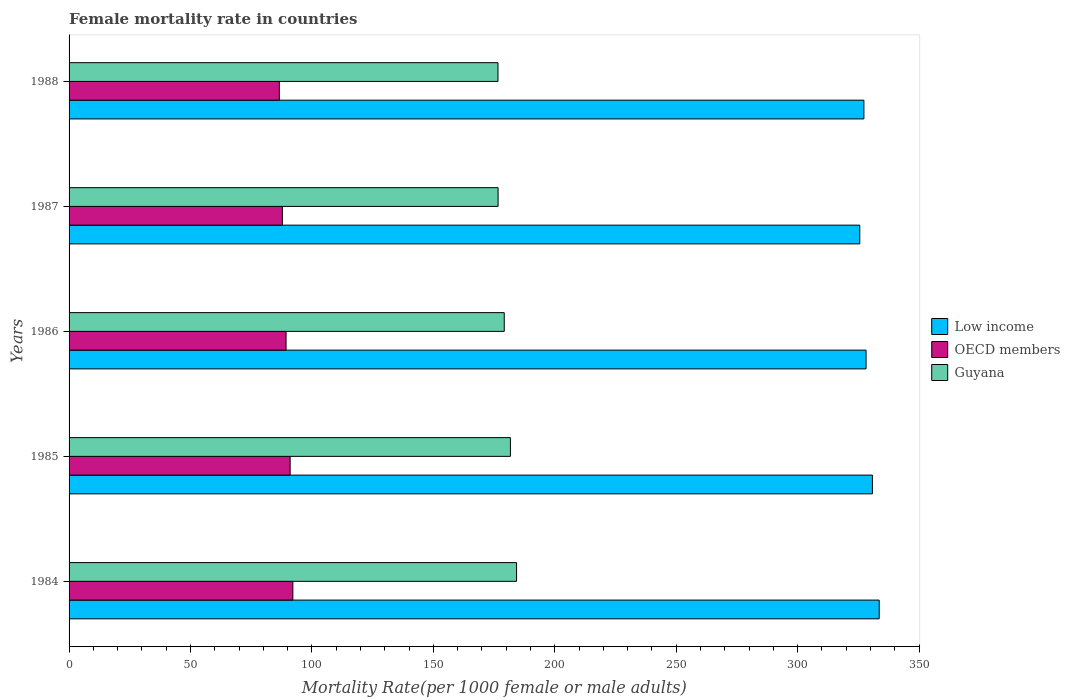Are the number of bars per tick equal to the number of legend labels?
Your answer should be very brief. Yes. How many bars are there on the 4th tick from the bottom?
Your answer should be very brief. 3. What is the label of the 2nd group of bars from the top?
Offer a terse response. 1987. What is the female mortality rate in Low income in 1988?
Your answer should be compact. 327.26. Across all years, what is the maximum female mortality rate in OECD members?
Your response must be concise. 92.13. Across all years, what is the minimum female mortality rate in OECD members?
Your response must be concise. 86.58. What is the total female mortality rate in Guyana in the graph?
Give a very brief answer. 898.39. What is the difference between the female mortality rate in OECD members in 1984 and that in 1988?
Keep it short and to the point. 5.55. What is the difference between the female mortality rate in Guyana in 1987 and the female mortality rate in OECD members in 1988?
Your response must be concise. 90.07. What is the average female mortality rate in Low income per year?
Your answer should be compact. 329.06. In the year 1984, what is the difference between the female mortality rate in Low income and female mortality rate in Guyana?
Give a very brief answer. 149.31. In how many years, is the female mortality rate in Low income greater than 100 ?
Ensure brevity in your answer.  5. What is the ratio of the female mortality rate in Low income in 1987 to that in 1988?
Ensure brevity in your answer.  0.99. What is the difference between the highest and the second highest female mortality rate in Guyana?
Make the answer very short. 2.53. What is the difference between the highest and the lowest female mortality rate in Guyana?
Give a very brief answer. 7.64. In how many years, is the female mortality rate in Low income greater than the average female mortality rate in Low income taken over all years?
Offer a terse response. 2. Is the sum of the female mortality rate in Guyana in 1984 and 1986 greater than the maximum female mortality rate in OECD members across all years?
Your answer should be compact. Yes. What does the 3rd bar from the bottom in 1987 represents?
Offer a very short reply. Guyana. Is it the case that in every year, the sum of the female mortality rate in Guyana and female mortality rate in OECD members is greater than the female mortality rate in Low income?
Your answer should be very brief. No. How many bars are there?
Give a very brief answer. 15. Are all the bars in the graph horizontal?
Your answer should be very brief. Yes. How many years are there in the graph?
Your answer should be very brief. 5. What is the difference between two consecutive major ticks on the X-axis?
Provide a short and direct response. 50. Are the values on the major ticks of X-axis written in scientific E-notation?
Offer a terse response. No. Does the graph contain any zero values?
Ensure brevity in your answer.  No. Where does the legend appear in the graph?
Keep it short and to the point. Center right. How many legend labels are there?
Offer a terse response. 3. How are the legend labels stacked?
Provide a short and direct response. Vertical. What is the title of the graph?
Give a very brief answer. Female mortality rate in countries. What is the label or title of the X-axis?
Offer a very short reply. Mortality Rate(per 1000 female or male adults). What is the Mortality Rate(per 1000 female or male adults) in Low income in 1984?
Offer a terse response. 333.55. What is the Mortality Rate(per 1000 female or male adults) in OECD members in 1984?
Give a very brief answer. 92.13. What is the Mortality Rate(per 1000 female or male adults) in Guyana in 1984?
Your answer should be compact. 184.25. What is the Mortality Rate(per 1000 female or male adults) in Low income in 1985?
Your answer should be very brief. 330.76. What is the Mortality Rate(per 1000 female or male adults) of OECD members in 1985?
Offer a terse response. 91.02. What is the Mortality Rate(per 1000 female or male adults) of Guyana in 1985?
Keep it short and to the point. 181.71. What is the Mortality Rate(per 1000 female or male adults) of Low income in 1986?
Your answer should be compact. 328.15. What is the Mortality Rate(per 1000 female or male adults) of OECD members in 1986?
Your response must be concise. 89.35. What is the Mortality Rate(per 1000 female or male adults) in Guyana in 1986?
Keep it short and to the point. 179.18. What is the Mortality Rate(per 1000 female or male adults) in Low income in 1987?
Keep it short and to the point. 325.56. What is the Mortality Rate(per 1000 female or male adults) in OECD members in 1987?
Provide a short and direct response. 87.83. What is the Mortality Rate(per 1000 female or male adults) in Guyana in 1987?
Make the answer very short. 176.64. What is the Mortality Rate(per 1000 female or male adults) in Low income in 1988?
Offer a terse response. 327.26. What is the Mortality Rate(per 1000 female or male adults) of OECD members in 1988?
Offer a very short reply. 86.58. What is the Mortality Rate(per 1000 female or male adults) of Guyana in 1988?
Keep it short and to the point. 176.6. Across all years, what is the maximum Mortality Rate(per 1000 female or male adults) in Low income?
Offer a terse response. 333.55. Across all years, what is the maximum Mortality Rate(per 1000 female or male adults) in OECD members?
Your response must be concise. 92.13. Across all years, what is the maximum Mortality Rate(per 1000 female or male adults) of Guyana?
Provide a succinct answer. 184.25. Across all years, what is the minimum Mortality Rate(per 1000 female or male adults) of Low income?
Ensure brevity in your answer.  325.56. Across all years, what is the minimum Mortality Rate(per 1000 female or male adults) in OECD members?
Your answer should be compact. 86.58. Across all years, what is the minimum Mortality Rate(per 1000 female or male adults) of Guyana?
Keep it short and to the point. 176.6. What is the total Mortality Rate(per 1000 female or male adults) of Low income in the graph?
Offer a very short reply. 1645.29. What is the total Mortality Rate(per 1000 female or male adults) in OECD members in the graph?
Your answer should be very brief. 446.9. What is the total Mortality Rate(per 1000 female or male adults) of Guyana in the graph?
Ensure brevity in your answer.  898.39. What is the difference between the Mortality Rate(per 1000 female or male adults) in Low income in 1984 and that in 1985?
Provide a short and direct response. 2.79. What is the difference between the Mortality Rate(per 1000 female or male adults) in Guyana in 1984 and that in 1985?
Provide a short and direct response. 2.53. What is the difference between the Mortality Rate(per 1000 female or male adults) in Low income in 1984 and that in 1986?
Keep it short and to the point. 5.41. What is the difference between the Mortality Rate(per 1000 female or male adults) in OECD members in 1984 and that in 1986?
Your response must be concise. 2.79. What is the difference between the Mortality Rate(per 1000 female or male adults) in Guyana in 1984 and that in 1986?
Give a very brief answer. 5.07. What is the difference between the Mortality Rate(per 1000 female or male adults) in Low income in 1984 and that in 1987?
Your answer should be very brief. 7.99. What is the difference between the Mortality Rate(per 1000 female or male adults) of OECD members in 1984 and that in 1987?
Ensure brevity in your answer.  4.31. What is the difference between the Mortality Rate(per 1000 female or male adults) in Guyana in 1984 and that in 1987?
Make the answer very short. 7.6. What is the difference between the Mortality Rate(per 1000 female or male adults) in Low income in 1984 and that in 1988?
Offer a very short reply. 6.29. What is the difference between the Mortality Rate(per 1000 female or male adults) in OECD members in 1984 and that in 1988?
Your response must be concise. 5.55. What is the difference between the Mortality Rate(per 1000 female or male adults) of Guyana in 1984 and that in 1988?
Offer a terse response. 7.64. What is the difference between the Mortality Rate(per 1000 female or male adults) in Low income in 1985 and that in 1986?
Offer a terse response. 2.62. What is the difference between the Mortality Rate(per 1000 female or male adults) in OECD members in 1985 and that in 1986?
Keep it short and to the point. 1.68. What is the difference between the Mortality Rate(per 1000 female or male adults) of Guyana in 1985 and that in 1986?
Offer a very short reply. 2.54. What is the difference between the Mortality Rate(per 1000 female or male adults) in Low income in 1985 and that in 1987?
Provide a short and direct response. 5.2. What is the difference between the Mortality Rate(per 1000 female or male adults) of OECD members in 1985 and that in 1987?
Your response must be concise. 3.2. What is the difference between the Mortality Rate(per 1000 female or male adults) in Guyana in 1985 and that in 1987?
Keep it short and to the point. 5.07. What is the difference between the Mortality Rate(per 1000 female or male adults) in Low income in 1985 and that in 1988?
Offer a terse response. 3.5. What is the difference between the Mortality Rate(per 1000 female or male adults) in OECD members in 1985 and that in 1988?
Offer a terse response. 4.44. What is the difference between the Mortality Rate(per 1000 female or male adults) in Guyana in 1985 and that in 1988?
Your response must be concise. 5.11. What is the difference between the Mortality Rate(per 1000 female or male adults) of Low income in 1986 and that in 1987?
Provide a short and direct response. 2.58. What is the difference between the Mortality Rate(per 1000 female or male adults) in OECD members in 1986 and that in 1987?
Provide a short and direct response. 1.52. What is the difference between the Mortality Rate(per 1000 female or male adults) of Guyana in 1986 and that in 1987?
Make the answer very short. 2.53. What is the difference between the Mortality Rate(per 1000 female or male adults) in Low income in 1986 and that in 1988?
Your answer should be very brief. 0.89. What is the difference between the Mortality Rate(per 1000 female or male adults) in OECD members in 1986 and that in 1988?
Offer a very short reply. 2.77. What is the difference between the Mortality Rate(per 1000 female or male adults) of Guyana in 1986 and that in 1988?
Offer a very short reply. 2.57. What is the difference between the Mortality Rate(per 1000 female or male adults) in Low income in 1987 and that in 1988?
Offer a terse response. -1.7. What is the difference between the Mortality Rate(per 1000 female or male adults) of OECD members in 1987 and that in 1988?
Your answer should be compact. 1.25. What is the difference between the Mortality Rate(per 1000 female or male adults) of Guyana in 1987 and that in 1988?
Your answer should be compact. 0.04. What is the difference between the Mortality Rate(per 1000 female or male adults) in Low income in 1984 and the Mortality Rate(per 1000 female or male adults) in OECD members in 1985?
Give a very brief answer. 242.53. What is the difference between the Mortality Rate(per 1000 female or male adults) in Low income in 1984 and the Mortality Rate(per 1000 female or male adults) in Guyana in 1985?
Keep it short and to the point. 151.84. What is the difference between the Mortality Rate(per 1000 female or male adults) in OECD members in 1984 and the Mortality Rate(per 1000 female or male adults) in Guyana in 1985?
Make the answer very short. -89.58. What is the difference between the Mortality Rate(per 1000 female or male adults) in Low income in 1984 and the Mortality Rate(per 1000 female or male adults) in OECD members in 1986?
Make the answer very short. 244.21. What is the difference between the Mortality Rate(per 1000 female or male adults) in Low income in 1984 and the Mortality Rate(per 1000 female or male adults) in Guyana in 1986?
Offer a very short reply. 154.38. What is the difference between the Mortality Rate(per 1000 female or male adults) of OECD members in 1984 and the Mortality Rate(per 1000 female or male adults) of Guyana in 1986?
Give a very brief answer. -87.05. What is the difference between the Mortality Rate(per 1000 female or male adults) in Low income in 1984 and the Mortality Rate(per 1000 female or male adults) in OECD members in 1987?
Your answer should be very brief. 245.73. What is the difference between the Mortality Rate(per 1000 female or male adults) in Low income in 1984 and the Mortality Rate(per 1000 female or male adults) in Guyana in 1987?
Give a very brief answer. 156.91. What is the difference between the Mortality Rate(per 1000 female or male adults) of OECD members in 1984 and the Mortality Rate(per 1000 female or male adults) of Guyana in 1987?
Keep it short and to the point. -84.51. What is the difference between the Mortality Rate(per 1000 female or male adults) of Low income in 1984 and the Mortality Rate(per 1000 female or male adults) of OECD members in 1988?
Your answer should be very brief. 246.98. What is the difference between the Mortality Rate(per 1000 female or male adults) in Low income in 1984 and the Mortality Rate(per 1000 female or male adults) in Guyana in 1988?
Ensure brevity in your answer.  156.95. What is the difference between the Mortality Rate(per 1000 female or male adults) in OECD members in 1984 and the Mortality Rate(per 1000 female or male adults) in Guyana in 1988?
Ensure brevity in your answer.  -84.47. What is the difference between the Mortality Rate(per 1000 female or male adults) of Low income in 1985 and the Mortality Rate(per 1000 female or male adults) of OECD members in 1986?
Your response must be concise. 241.42. What is the difference between the Mortality Rate(per 1000 female or male adults) of Low income in 1985 and the Mortality Rate(per 1000 female or male adults) of Guyana in 1986?
Make the answer very short. 151.59. What is the difference between the Mortality Rate(per 1000 female or male adults) of OECD members in 1985 and the Mortality Rate(per 1000 female or male adults) of Guyana in 1986?
Your answer should be compact. -88.16. What is the difference between the Mortality Rate(per 1000 female or male adults) in Low income in 1985 and the Mortality Rate(per 1000 female or male adults) in OECD members in 1987?
Keep it short and to the point. 242.94. What is the difference between the Mortality Rate(per 1000 female or male adults) in Low income in 1985 and the Mortality Rate(per 1000 female or male adults) in Guyana in 1987?
Your response must be concise. 154.12. What is the difference between the Mortality Rate(per 1000 female or male adults) in OECD members in 1985 and the Mortality Rate(per 1000 female or male adults) in Guyana in 1987?
Offer a terse response. -85.62. What is the difference between the Mortality Rate(per 1000 female or male adults) of Low income in 1985 and the Mortality Rate(per 1000 female or male adults) of OECD members in 1988?
Your response must be concise. 244.19. What is the difference between the Mortality Rate(per 1000 female or male adults) in Low income in 1985 and the Mortality Rate(per 1000 female or male adults) in Guyana in 1988?
Ensure brevity in your answer.  154.16. What is the difference between the Mortality Rate(per 1000 female or male adults) of OECD members in 1985 and the Mortality Rate(per 1000 female or male adults) of Guyana in 1988?
Offer a terse response. -85.58. What is the difference between the Mortality Rate(per 1000 female or male adults) in Low income in 1986 and the Mortality Rate(per 1000 female or male adults) in OECD members in 1987?
Ensure brevity in your answer.  240.32. What is the difference between the Mortality Rate(per 1000 female or male adults) in Low income in 1986 and the Mortality Rate(per 1000 female or male adults) in Guyana in 1987?
Offer a very short reply. 151.5. What is the difference between the Mortality Rate(per 1000 female or male adults) in OECD members in 1986 and the Mortality Rate(per 1000 female or male adults) in Guyana in 1987?
Your answer should be compact. -87.3. What is the difference between the Mortality Rate(per 1000 female or male adults) in Low income in 1986 and the Mortality Rate(per 1000 female or male adults) in OECD members in 1988?
Offer a very short reply. 241.57. What is the difference between the Mortality Rate(per 1000 female or male adults) in Low income in 1986 and the Mortality Rate(per 1000 female or male adults) in Guyana in 1988?
Provide a succinct answer. 151.54. What is the difference between the Mortality Rate(per 1000 female or male adults) of OECD members in 1986 and the Mortality Rate(per 1000 female or male adults) of Guyana in 1988?
Your answer should be compact. -87.26. What is the difference between the Mortality Rate(per 1000 female or male adults) of Low income in 1987 and the Mortality Rate(per 1000 female or male adults) of OECD members in 1988?
Provide a succinct answer. 238.99. What is the difference between the Mortality Rate(per 1000 female or male adults) in Low income in 1987 and the Mortality Rate(per 1000 female or male adults) in Guyana in 1988?
Your answer should be very brief. 148.96. What is the difference between the Mortality Rate(per 1000 female or male adults) in OECD members in 1987 and the Mortality Rate(per 1000 female or male adults) in Guyana in 1988?
Offer a very short reply. -88.78. What is the average Mortality Rate(per 1000 female or male adults) of Low income per year?
Offer a very short reply. 329.06. What is the average Mortality Rate(per 1000 female or male adults) of OECD members per year?
Ensure brevity in your answer.  89.38. What is the average Mortality Rate(per 1000 female or male adults) in Guyana per year?
Your answer should be very brief. 179.68. In the year 1984, what is the difference between the Mortality Rate(per 1000 female or male adults) of Low income and Mortality Rate(per 1000 female or male adults) of OECD members?
Make the answer very short. 241.42. In the year 1984, what is the difference between the Mortality Rate(per 1000 female or male adults) in Low income and Mortality Rate(per 1000 female or male adults) in Guyana?
Ensure brevity in your answer.  149.31. In the year 1984, what is the difference between the Mortality Rate(per 1000 female or male adults) in OECD members and Mortality Rate(per 1000 female or male adults) in Guyana?
Give a very brief answer. -92.11. In the year 1985, what is the difference between the Mortality Rate(per 1000 female or male adults) of Low income and Mortality Rate(per 1000 female or male adults) of OECD members?
Ensure brevity in your answer.  239.74. In the year 1985, what is the difference between the Mortality Rate(per 1000 female or male adults) in Low income and Mortality Rate(per 1000 female or male adults) in Guyana?
Provide a short and direct response. 149.05. In the year 1985, what is the difference between the Mortality Rate(per 1000 female or male adults) of OECD members and Mortality Rate(per 1000 female or male adults) of Guyana?
Your response must be concise. -90.69. In the year 1986, what is the difference between the Mortality Rate(per 1000 female or male adults) in Low income and Mortality Rate(per 1000 female or male adults) in OECD members?
Keep it short and to the point. 238.8. In the year 1986, what is the difference between the Mortality Rate(per 1000 female or male adults) of Low income and Mortality Rate(per 1000 female or male adults) of Guyana?
Keep it short and to the point. 148.97. In the year 1986, what is the difference between the Mortality Rate(per 1000 female or male adults) of OECD members and Mortality Rate(per 1000 female or male adults) of Guyana?
Keep it short and to the point. -89.83. In the year 1987, what is the difference between the Mortality Rate(per 1000 female or male adults) of Low income and Mortality Rate(per 1000 female or male adults) of OECD members?
Keep it short and to the point. 237.74. In the year 1987, what is the difference between the Mortality Rate(per 1000 female or male adults) of Low income and Mortality Rate(per 1000 female or male adults) of Guyana?
Your answer should be very brief. 148.92. In the year 1987, what is the difference between the Mortality Rate(per 1000 female or male adults) of OECD members and Mortality Rate(per 1000 female or male adults) of Guyana?
Offer a very short reply. -88.82. In the year 1988, what is the difference between the Mortality Rate(per 1000 female or male adults) in Low income and Mortality Rate(per 1000 female or male adults) in OECD members?
Your answer should be compact. 240.68. In the year 1988, what is the difference between the Mortality Rate(per 1000 female or male adults) in Low income and Mortality Rate(per 1000 female or male adults) in Guyana?
Provide a succinct answer. 150.66. In the year 1988, what is the difference between the Mortality Rate(per 1000 female or male adults) of OECD members and Mortality Rate(per 1000 female or male adults) of Guyana?
Offer a very short reply. -90.03. What is the ratio of the Mortality Rate(per 1000 female or male adults) of Low income in 1984 to that in 1985?
Your answer should be very brief. 1.01. What is the ratio of the Mortality Rate(per 1000 female or male adults) of OECD members in 1984 to that in 1985?
Your answer should be compact. 1.01. What is the ratio of the Mortality Rate(per 1000 female or male adults) of Guyana in 1984 to that in 1985?
Provide a short and direct response. 1.01. What is the ratio of the Mortality Rate(per 1000 female or male adults) of Low income in 1984 to that in 1986?
Your answer should be very brief. 1.02. What is the ratio of the Mortality Rate(per 1000 female or male adults) of OECD members in 1984 to that in 1986?
Offer a very short reply. 1.03. What is the ratio of the Mortality Rate(per 1000 female or male adults) in Guyana in 1984 to that in 1986?
Your answer should be compact. 1.03. What is the ratio of the Mortality Rate(per 1000 female or male adults) in Low income in 1984 to that in 1987?
Offer a very short reply. 1.02. What is the ratio of the Mortality Rate(per 1000 female or male adults) of OECD members in 1984 to that in 1987?
Give a very brief answer. 1.05. What is the ratio of the Mortality Rate(per 1000 female or male adults) of Guyana in 1984 to that in 1987?
Offer a very short reply. 1.04. What is the ratio of the Mortality Rate(per 1000 female or male adults) in Low income in 1984 to that in 1988?
Provide a succinct answer. 1.02. What is the ratio of the Mortality Rate(per 1000 female or male adults) in OECD members in 1984 to that in 1988?
Your answer should be compact. 1.06. What is the ratio of the Mortality Rate(per 1000 female or male adults) in Guyana in 1984 to that in 1988?
Give a very brief answer. 1.04. What is the ratio of the Mortality Rate(per 1000 female or male adults) in Low income in 1985 to that in 1986?
Ensure brevity in your answer.  1.01. What is the ratio of the Mortality Rate(per 1000 female or male adults) of OECD members in 1985 to that in 1986?
Provide a succinct answer. 1.02. What is the ratio of the Mortality Rate(per 1000 female or male adults) in Guyana in 1985 to that in 1986?
Offer a very short reply. 1.01. What is the ratio of the Mortality Rate(per 1000 female or male adults) in OECD members in 1985 to that in 1987?
Give a very brief answer. 1.04. What is the ratio of the Mortality Rate(per 1000 female or male adults) in Guyana in 1985 to that in 1987?
Your answer should be very brief. 1.03. What is the ratio of the Mortality Rate(per 1000 female or male adults) in Low income in 1985 to that in 1988?
Provide a succinct answer. 1.01. What is the ratio of the Mortality Rate(per 1000 female or male adults) of OECD members in 1985 to that in 1988?
Keep it short and to the point. 1.05. What is the ratio of the Mortality Rate(per 1000 female or male adults) of Guyana in 1985 to that in 1988?
Offer a terse response. 1.03. What is the ratio of the Mortality Rate(per 1000 female or male adults) in Low income in 1986 to that in 1987?
Offer a terse response. 1.01. What is the ratio of the Mortality Rate(per 1000 female or male adults) of OECD members in 1986 to that in 1987?
Make the answer very short. 1.02. What is the ratio of the Mortality Rate(per 1000 female or male adults) in Guyana in 1986 to that in 1987?
Your answer should be very brief. 1.01. What is the ratio of the Mortality Rate(per 1000 female or male adults) of OECD members in 1986 to that in 1988?
Keep it short and to the point. 1.03. What is the ratio of the Mortality Rate(per 1000 female or male adults) of Guyana in 1986 to that in 1988?
Keep it short and to the point. 1.01. What is the ratio of the Mortality Rate(per 1000 female or male adults) in Low income in 1987 to that in 1988?
Ensure brevity in your answer.  0.99. What is the ratio of the Mortality Rate(per 1000 female or male adults) of OECD members in 1987 to that in 1988?
Provide a succinct answer. 1.01. What is the difference between the highest and the second highest Mortality Rate(per 1000 female or male adults) in Low income?
Keep it short and to the point. 2.79. What is the difference between the highest and the second highest Mortality Rate(per 1000 female or male adults) of OECD members?
Provide a short and direct response. 1.11. What is the difference between the highest and the second highest Mortality Rate(per 1000 female or male adults) in Guyana?
Your answer should be compact. 2.53. What is the difference between the highest and the lowest Mortality Rate(per 1000 female or male adults) in Low income?
Offer a terse response. 7.99. What is the difference between the highest and the lowest Mortality Rate(per 1000 female or male adults) of OECD members?
Ensure brevity in your answer.  5.55. What is the difference between the highest and the lowest Mortality Rate(per 1000 female or male adults) of Guyana?
Provide a succinct answer. 7.64. 